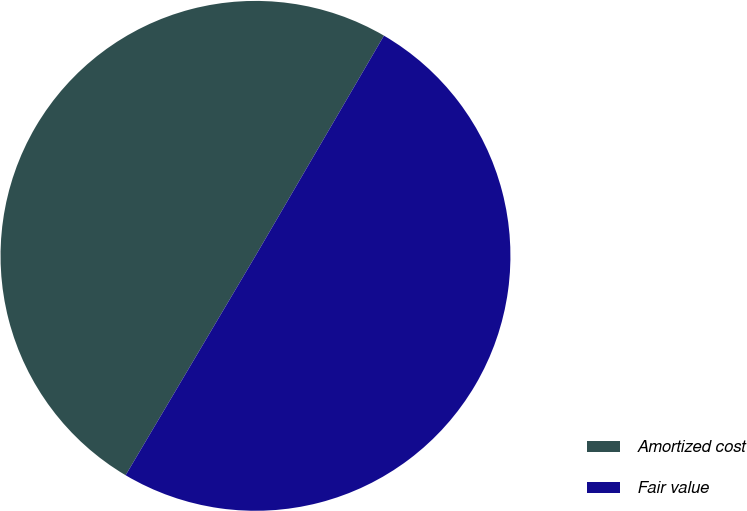Convert chart. <chart><loc_0><loc_0><loc_500><loc_500><pie_chart><fcel>Amortized cost<fcel>Fair value<nl><fcel>49.9%<fcel>50.1%<nl></chart> 